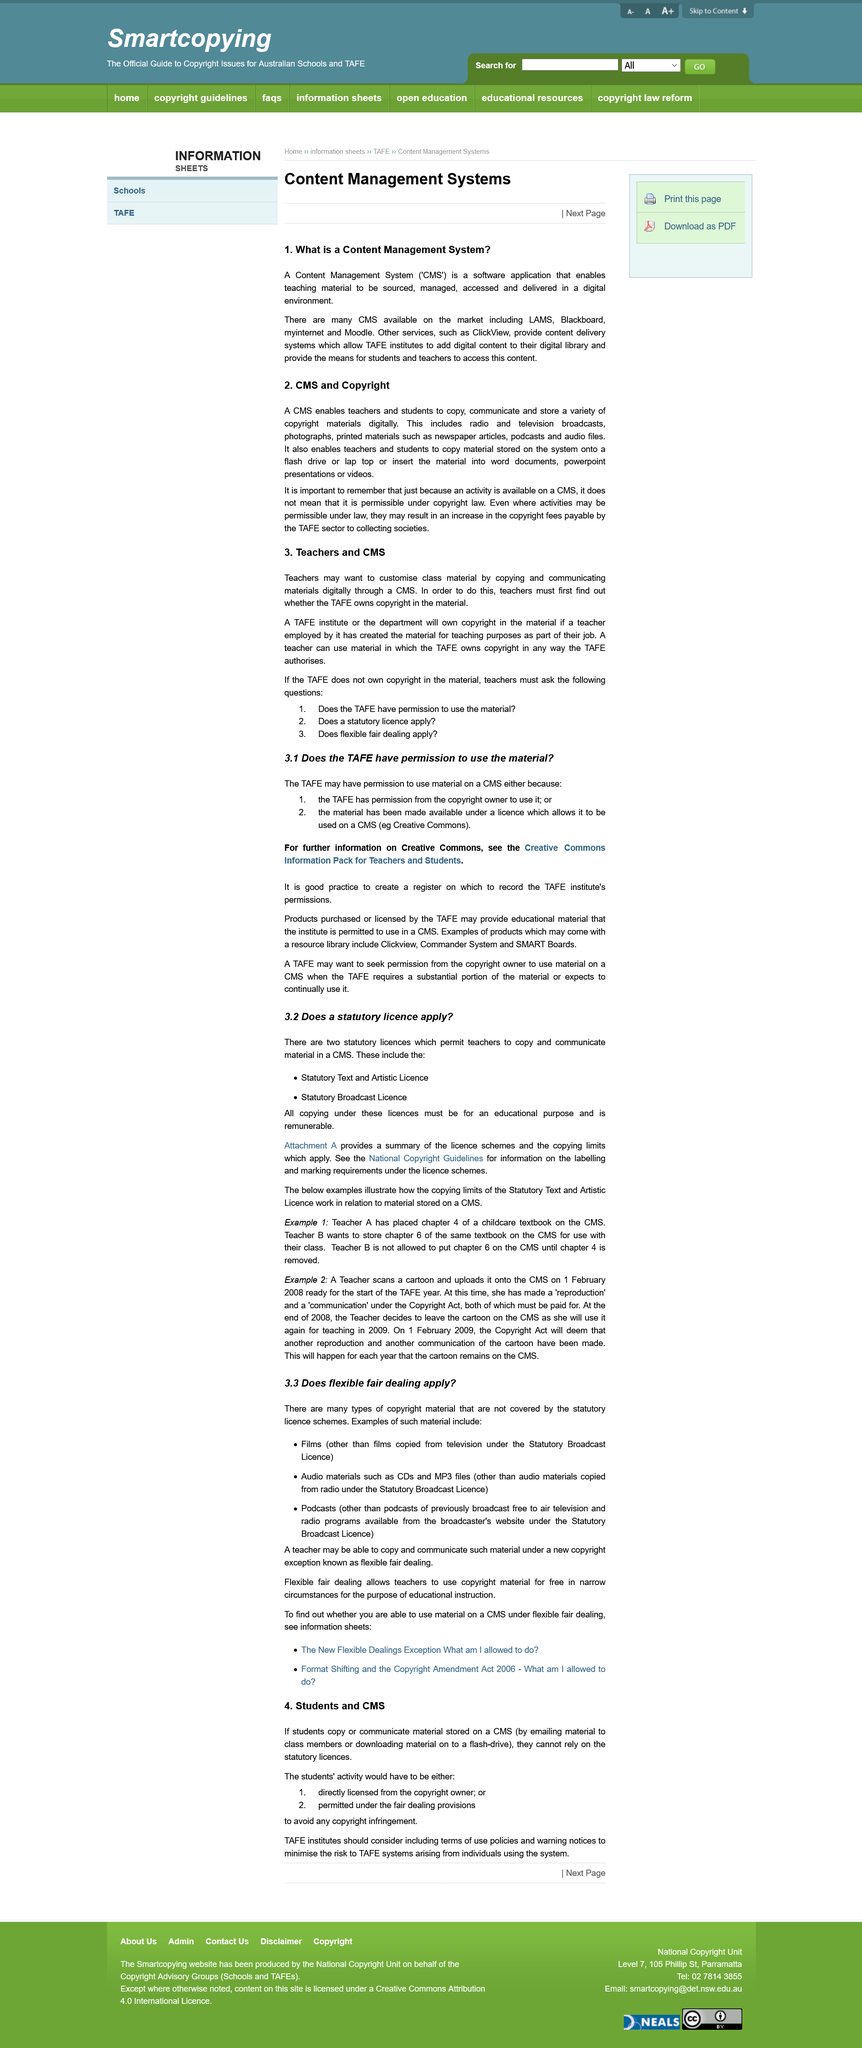Point out several critical features in this image. The title of the article is "What is the title of the article? CMS and Copyright..". When a TAFE institute or the department owns the copyright in material that has been created by a teacher for teaching purposes as part of their job, the institute or department will have the exclusive rights to use, adapt, and reproduce the material for educational purposes. The licenses serve the purpose of allowing teachers to copy and communicate materials within a CMS. Teachers should ask three questions if the TAFE does not own the copyright in the material they are using in their teaching. There are two licenses that allow teachers to copy and communicate materials in a CMS. 